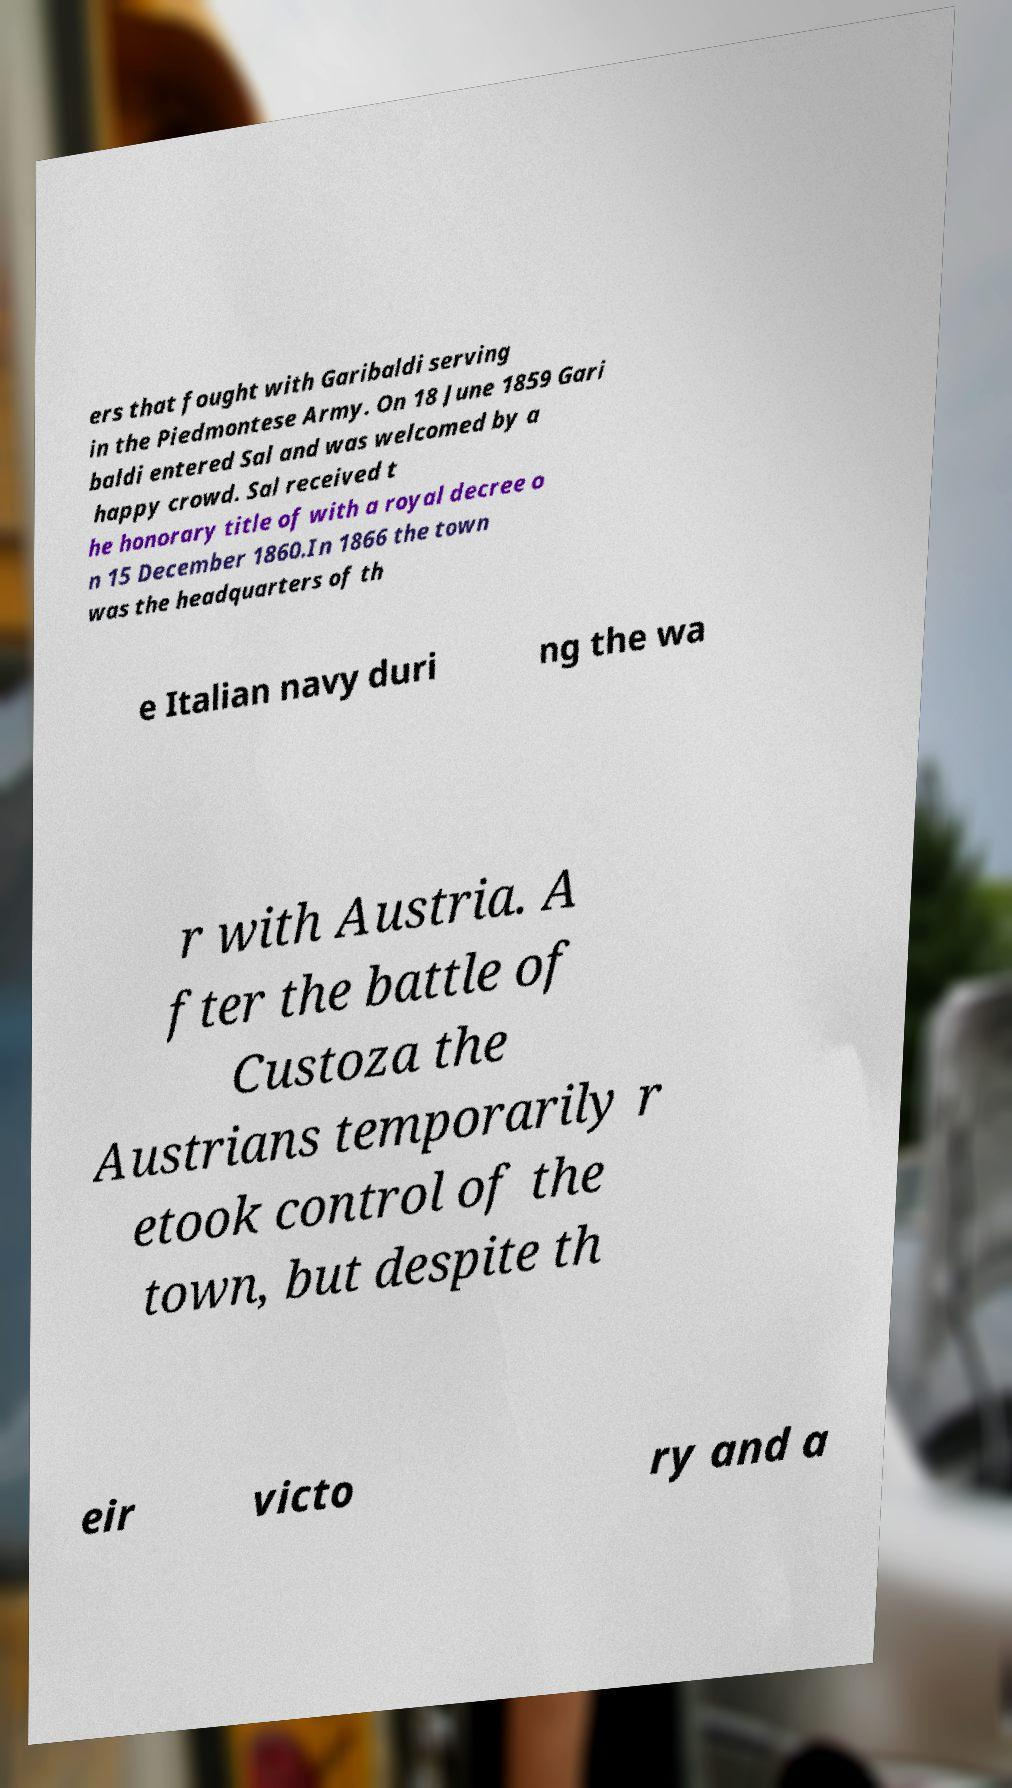Please read and relay the text visible in this image. What does it say? ers that fought with Garibaldi serving in the Piedmontese Army. On 18 June 1859 Gari baldi entered Sal and was welcomed by a happy crowd. Sal received t he honorary title of with a royal decree o n 15 December 1860.In 1866 the town was the headquarters of th e Italian navy duri ng the wa r with Austria. A fter the battle of Custoza the Austrians temporarily r etook control of the town, but despite th eir victo ry and a 